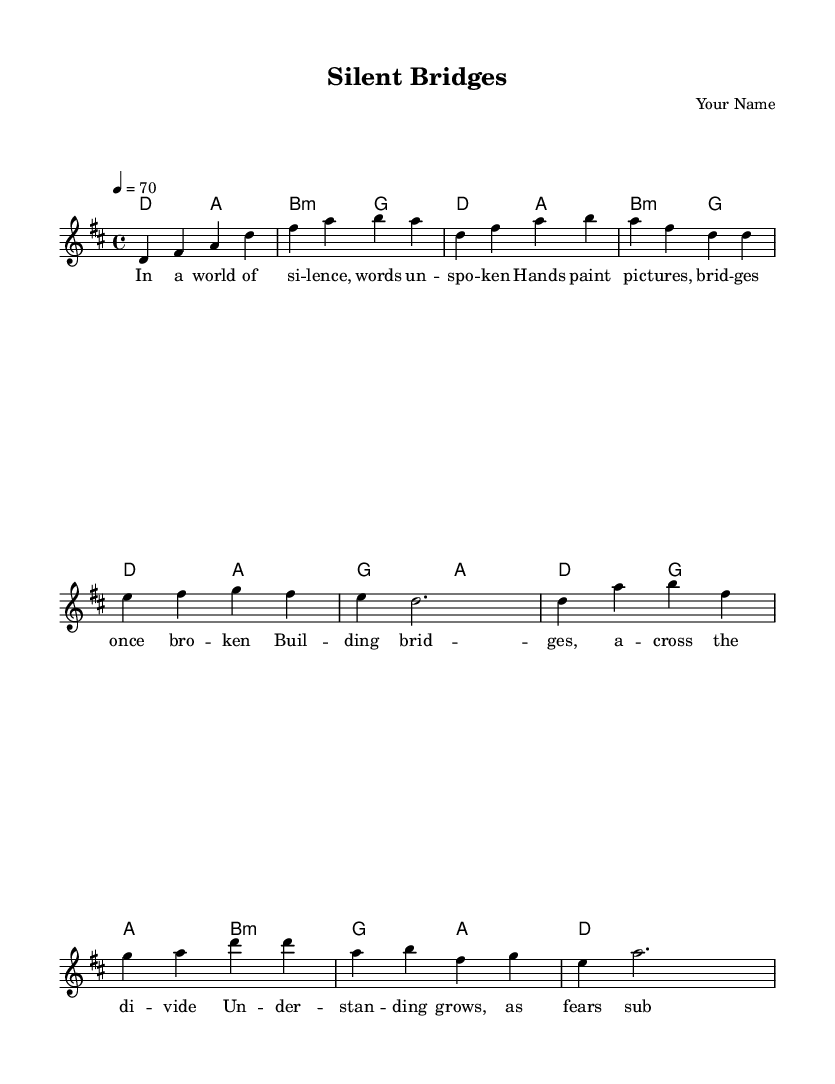What is the key signature of this music? The key signature is D major, which has two sharps: F# and C#.
Answer: D major What is the time signature of this piece? The time signature is 4/4, indicating four beats per measure with a quarter note receiving one beat.
Answer: 4/4 What is the indicated tempo for the music? The tempo is marked as 4 = 70, meaning the quarter note should be played at a speed of 70 beats per minute.
Answer: 70 How many measures are there in the verse? The verse consists of four measures, as indicated by the repeated notes and the structure within the music.
Answer: 4 What is the primary theme explored in the lyrics? The primary theme of the lyrics centers around communication and understanding, particularly focusing on the metaphor of building bridges.
Answer: Communication What is the first chord played in the intro? The first chord in the intro is D major, as shown by the chord in the chord progression at the beginning of the music.
Answer: D How does the chorus relate to the verse in terms of lyrical content? The chorus addresses the contrast between division and understanding, emphasizing emotional growth, which builds upon the verse's theme of silence and unspoken words.
Answer: Emotional growth 